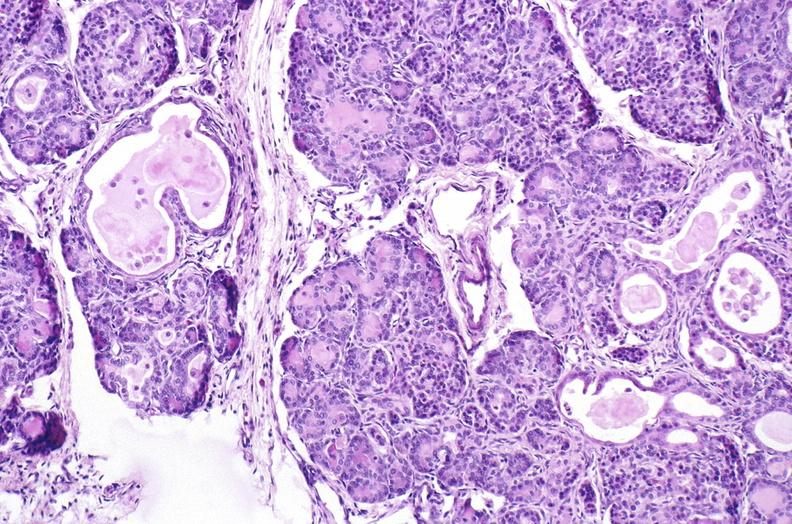where is this?
Answer the question using a single word or phrase. Pancreas 